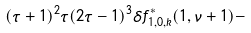Convert formula to latex. <formula><loc_0><loc_0><loc_500><loc_500>( \tau + 1 ) ^ { 2 } \tau ( 2 \tau - 1 ) ^ { 3 } \delta f _ { 1 , 0 , k } ^ { \ast } ( 1 , \nu + 1 ) -</formula> 